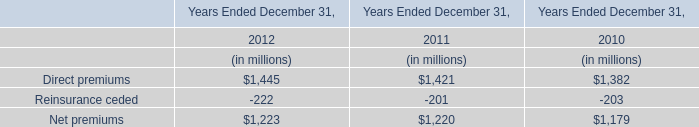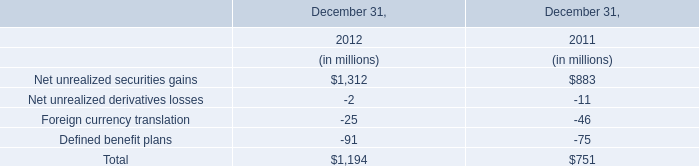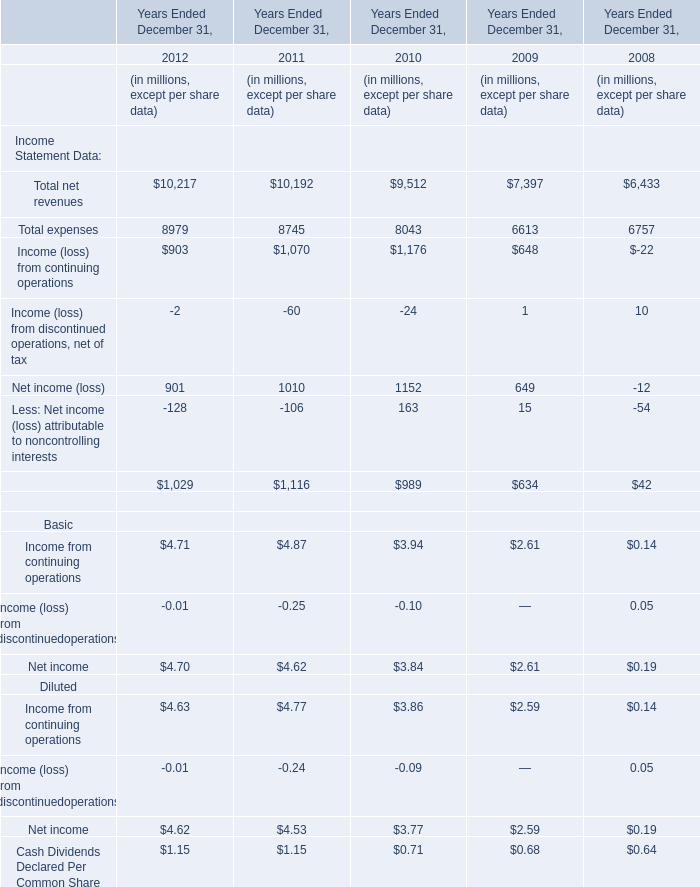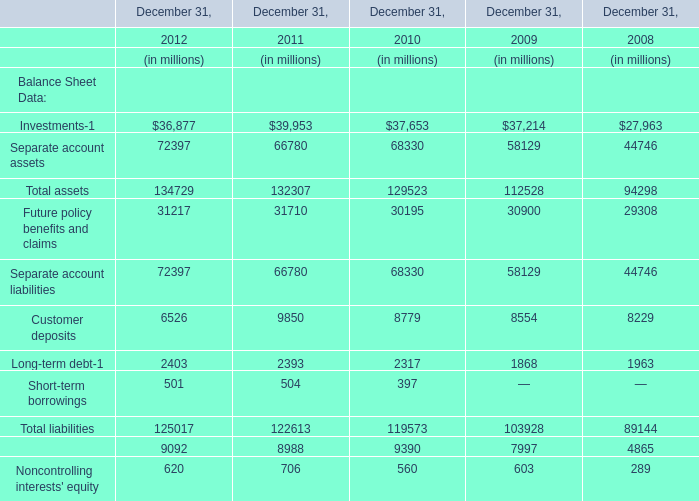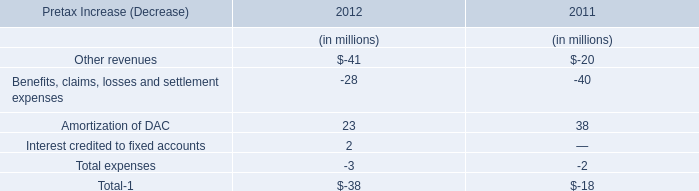What's the average of Total net revenues and Total expenses and Income (loss) from continuing operations in 2012? (in million) 
Computations: (((10217 + 8979) + 903) / 3)
Answer: 6699.66667. 